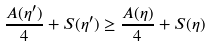Convert formula to latex. <formula><loc_0><loc_0><loc_500><loc_500>\frac { A ( \eta ^ { \prime } ) } { 4 } + S ( \eta ^ { \prime } ) \geq \frac { A ( \eta ) } { 4 } + S ( \eta )</formula> 